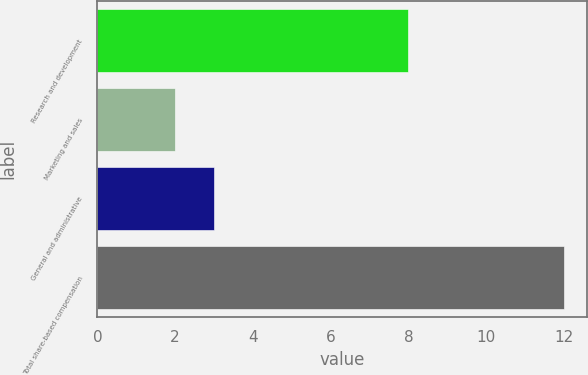<chart> <loc_0><loc_0><loc_500><loc_500><bar_chart><fcel>Research and development<fcel>Marketing and sales<fcel>General and administrative<fcel>Total share-based compensation<nl><fcel>8<fcel>2<fcel>3<fcel>12<nl></chart> 